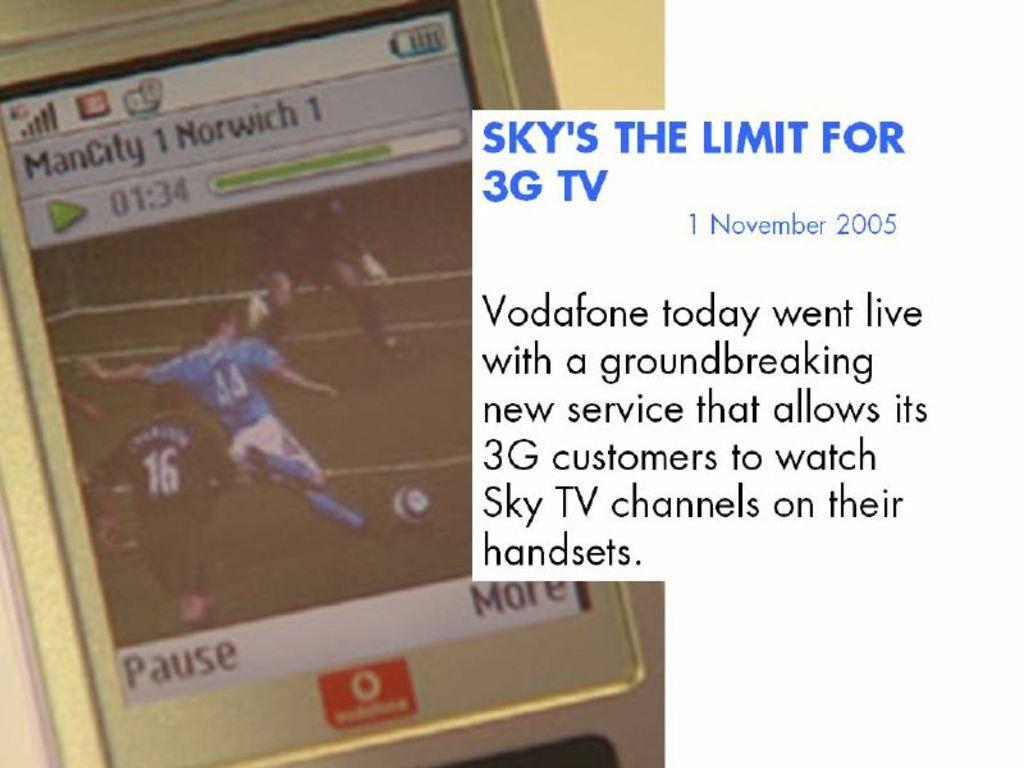<image>
Relay a brief, clear account of the picture shown. A cellphone in the background with an ad for Sky TV channels promoting that it's now available for 3G customers. 